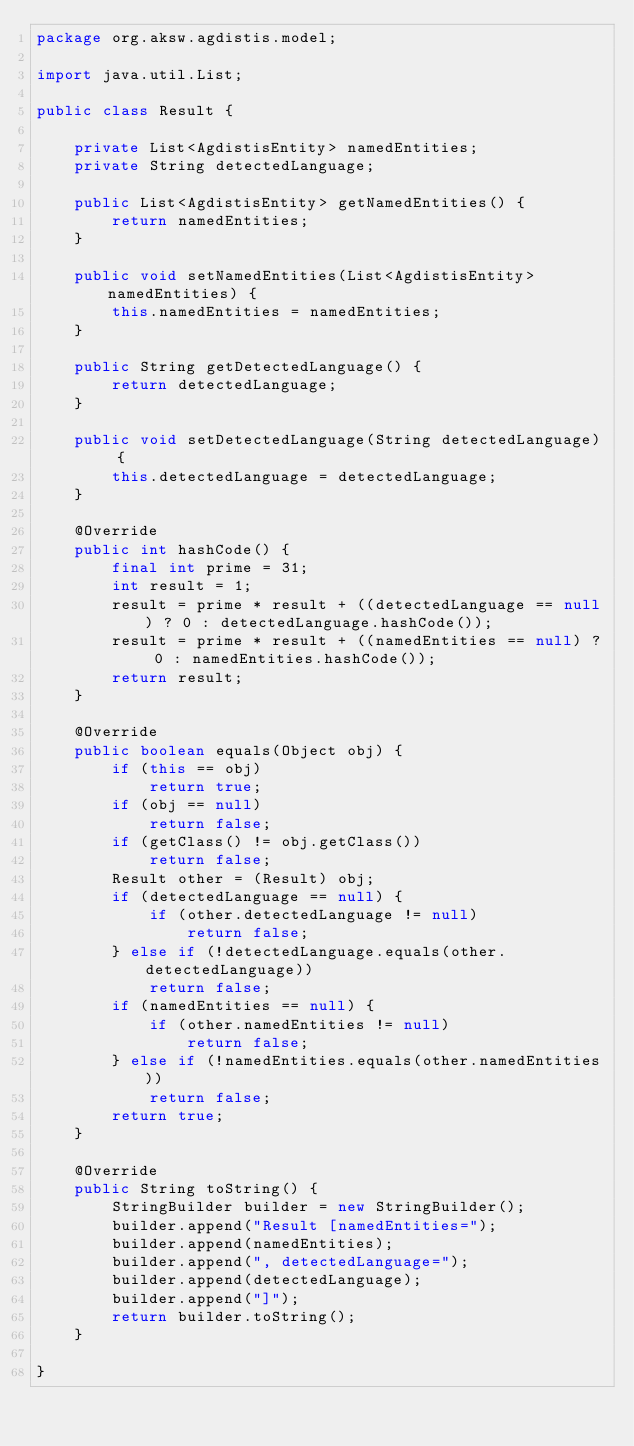Convert code to text. <code><loc_0><loc_0><loc_500><loc_500><_Java_>package org.aksw.agdistis.model;

import java.util.List;

public class Result {

	private List<AgdistisEntity> namedEntities;
	private String detectedLanguage;

	public List<AgdistisEntity> getNamedEntities() {
		return namedEntities;
	}

	public void setNamedEntities(List<AgdistisEntity> namedEntities) {
		this.namedEntities = namedEntities;
	}

	public String getDetectedLanguage() {
		return detectedLanguage;
	}

	public void setDetectedLanguage(String detectedLanguage) {
		this.detectedLanguage = detectedLanguage;
	}

	@Override
	public int hashCode() {
		final int prime = 31;
		int result = 1;
		result = prime * result + ((detectedLanguage == null) ? 0 : detectedLanguage.hashCode());
		result = prime * result + ((namedEntities == null) ? 0 : namedEntities.hashCode());
		return result;
	}

	@Override
	public boolean equals(Object obj) {
		if (this == obj)
			return true;
		if (obj == null)
			return false;
		if (getClass() != obj.getClass())
			return false;
		Result other = (Result) obj;
		if (detectedLanguage == null) {
			if (other.detectedLanguage != null)
				return false;
		} else if (!detectedLanguage.equals(other.detectedLanguage))
			return false;
		if (namedEntities == null) {
			if (other.namedEntities != null)
				return false;
		} else if (!namedEntities.equals(other.namedEntities))
			return false;
		return true;
	}

	@Override
	public String toString() {
		StringBuilder builder = new StringBuilder();
		builder.append("Result [namedEntities=");
		builder.append(namedEntities);
		builder.append(", detectedLanguage=");
		builder.append(detectedLanguage);
		builder.append("]");
		return builder.toString();
	}

}
</code> 